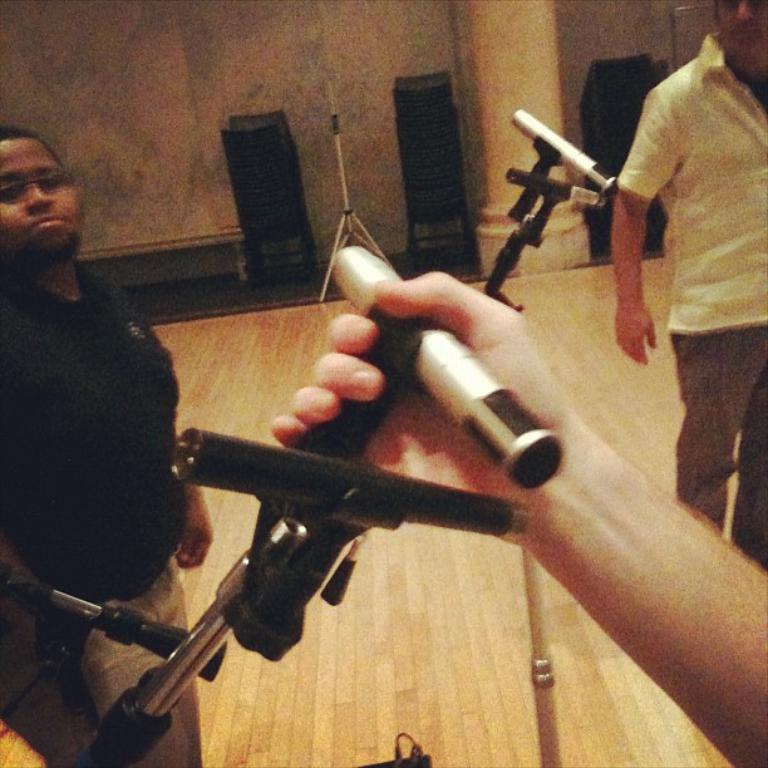What is being held by the person in the center of the image? There are objects in a person's hand in the center of the image. What can be seen in the background of the image? There are persons, a stand, a pillar, chairs, and a wall in the background of the image. What type of verse can be heard being recited by the person holding the apple in the image? There is no apple or verse present in the image; the person is holding objects, but their nature is not specified. 